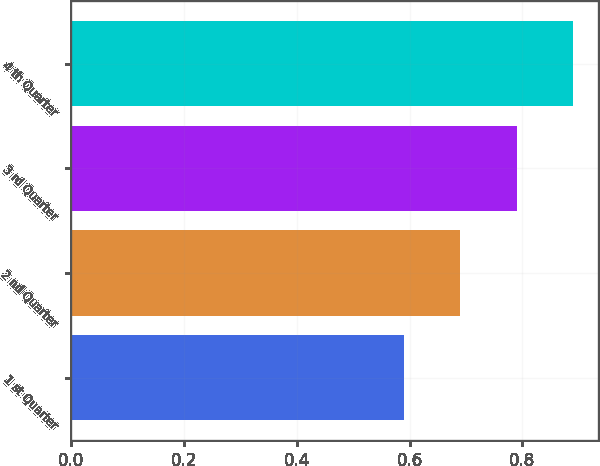Convert chart to OTSL. <chart><loc_0><loc_0><loc_500><loc_500><bar_chart><fcel>1 st Quarter<fcel>2 nd Quarter<fcel>3 rd Quarter<fcel>4 th Quarter<nl><fcel>0.59<fcel>0.69<fcel>0.79<fcel>0.89<nl></chart> 